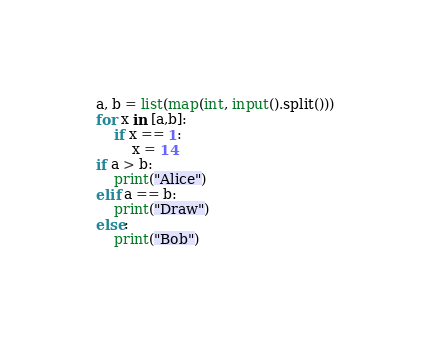Convert code to text. <code><loc_0><loc_0><loc_500><loc_500><_Python_>a, b = list(map(int, input().split()))
for x in [a,b]:
    if x == 1:
        x = 14
if a > b:
    print("Alice")
elif a == b:
    print("Draw")
else:
    print("Bob")</code> 